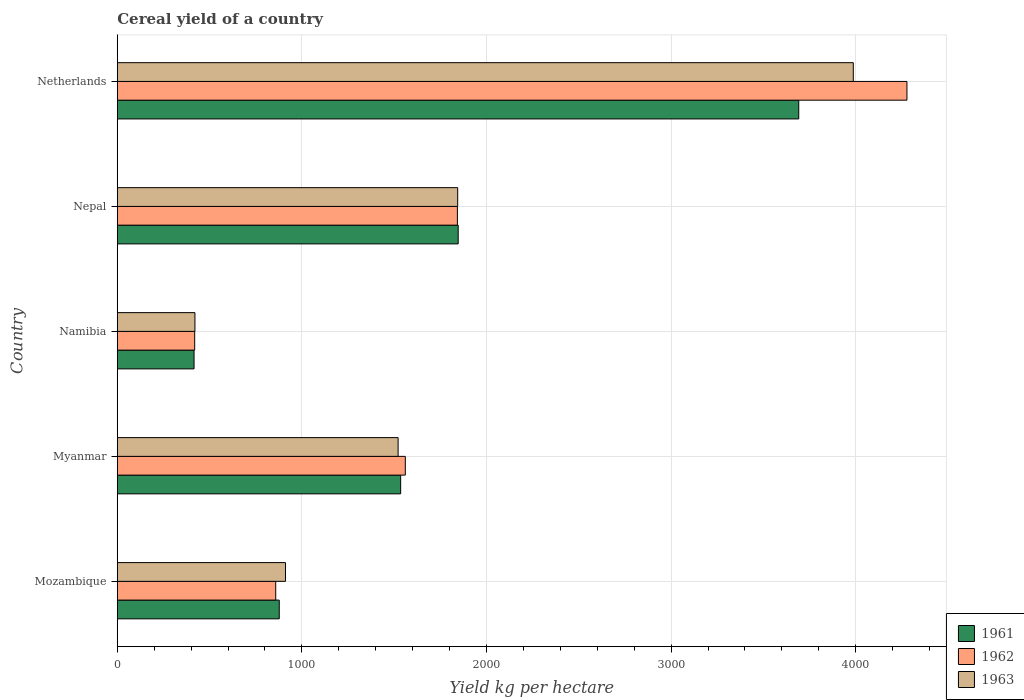How many groups of bars are there?
Provide a short and direct response. 5. Are the number of bars per tick equal to the number of legend labels?
Give a very brief answer. Yes. Are the number of bars on each tick of the Y-axis equal?
Provide a succinct answer. Yes. How many bars are there on the 5th tick from the top?
Provide a succinct answer. 3. How many bars are there on the 2nd tick from the bottom?
Your response must be concise. 3. What is the label of the 2nd group of bars from the top?
Your answer should be compact. Nepal. What is the total cereal yield in 1963 in Namibia?
Your response must be concise. 420.67. Across all countries, what is the maximum total cereal yield in 1961?
Your answer should be compact. 3691.39. Across all countries, what is the minimum total cereal yield in 1963?
Your response must be concise. 420.67. In which country was the total cereal yield in 1961 minimum?
Offer a terse response. Namibia. What is the total total cereal yield in 1961 in the graph?
Keep it short and to the point. 8366.16. What is the difference between the total cereal yield in 1962 in Mozambique and that in Netherlands?
Keep it short and to the point. -3419.19. What is the difference between the total cereal yield in 1963 in Myanmar and the total cereal yield in 1962 in Namibia?
Make the answer very short. 1101.84. What is the average total cereal yield in 1961 per country?
Provide a short and direct response. 1673.23. What is the difference between the total cereal yield in 1961 and total cereal yield in 1962 in Myanmar?
Provide a succinct answer. -25.2. In how many countries, is the total cereal yield in 1962 greater than 600 kg per hectare?
Offer a terse response. 4. What is the ratio of the total cereal yield in 1961 in Mozambique to that in Myanmar?
Your answer should be very brief. 0.57. What is the difference between the highest and the second highest total cereal yield in 1962?
Provide a short and direct response. 2435.14. What is the difference between the highest and the lowest total cereal yield in 1962?
Offer a very short reply. 3858.11. In how many countries, is the total cereal yield in 1961 greater than the average total cereal yield in 1961 taken over all countries?
Ensure brevity in your answer.  2. Is the sum of the total cereal yield in 1961 in Myanmar and Netherlands greater than the maximum total cereal yield in 1962 across all countries?
Make the answer very short. Yes. What does the 2nd bar from the bottom in Netherlands represents?
Offer a terse response. 1962. How many countries are there in the graph?
Provide a short and direct response. 5. Does the graph contain any zero values?
Your answer should be compact. No. How are the legend labels stacked?
Your response must be concise. Vertical. What is the title of the graph?
Your response must be concise. Cereal yield of a country. Does "1967" appear as one of the legend labels in the graph?
Give a very brief answer. No. What is the label or title of the X-axis?
Your response must be concise. Yield kg per hectare. What is the label or title of the Y-axis?
Offer a very short reply. Country. What is the Yield kg per hectare of 1961 in Mozambique?
Keep it short and to the point. 877.38. What is the Yield kg per hectare in 1962 in Mozambique?
Your answer should be very brief. 858.24. What is the Yield kg per hectare of 1963 in Mozambique?
Make the answer very short. 911.12. What is the Yield kg per hectare in 1961 in Myanmar?
Ensure brevity in your answer.  1534.96. What is the Yield kg per hectare in 1962 in Myanmar?
Your answer should be very brief. 1560.16. What is the Yield kg per hectare in 1963 in Myanmar?
Your answer should be very brief. 1521.16. What is the Yield kg per hectare in 1961 in Namibia?
Your response must be concise. 415.79. What is the Yield kg per hectare in 1962 in Namibia?
Your response must be concise. 419.32. What is the Yield kg per hectare of 1963 in Namibia?
Provide a succinct answer. 420.67. What is the Yield kg per hectare of 1961 in Nepal?
Ensure brevity in your answer.  1846.65. What is the Yield kg per hectare of 1962 in Nepal?
Provide a succinct answer. 1842.29. What is the Yield kg per hectare in 1963 in Nepal?
Your answer should be very brief. 1843.86. What is the Yield kg per hectare in 1961 in Netherlands?
Keep it short and to the point. 3691.39. What is the Yield kg per hectare in 1962 in Netherlands?
Provide a succinct answer. 4277.43. What is the Yield kg per hectare of 1963 in Netherlands?
Keep it short and to the point. 3986.86. Across all countries, what is the maximum Yield kg per hectare of 1961?
Offer a very short reply. 3691.39. Across all countries, what is the maximum Yield kg per hectare in 1962?
Your answer should be compact. 4277.43. Across all countries, what is the maximum Yield kg per hectare of 1963?
Your response must be concise. 3986.86. Across all countries, what is the minimum Yield kg per hectare in 1961?
Provide a succinct answer. 415.79. Across all countries, what is the minimum Yield kg per hectare in 1962?
Your answer should be very brief. 419.32. Across all countries, what is the minimum Yield kg per hectare of 1963?
Your response must be concise. 420.67. What is the total Yield kg per hectare of 1961 in the graph?
Offer a terse response. 8366.16. What is the total Yield kg per hectare of 1962 in the graph?
Ensure brevity in your answer.  8957.44. What is the total Yield kg per hectare of 1963 in the graph?
Make the answer very short. 8683.67. What is the difference between the Yield kg per hectare in 1961 in Mozambique and that in Myanmar?
Make the answer very short. -657.59. What is the difference between the Yield kg per hectare in 1962 in Mozambique and that in Myanmar?
Offer a very short reply. -701.92. What is the difference between the Yield kg per hectare in 1963 in Mozambique and that in Myanmar?
Ensure brevity in your answer.  -610.04. What is the difference between the Yield kg per hectare in 1961 in Mozambique and that in Namibia?
Offer a terse response. 461.58. What is the difference between the Yield kg per hectare in 1962 in Mozambique and that in Namibia?
Your answer should be compact. 438.92. What is the difference between the Yield kg per hectare of 1963 in Mozambique and that in Namibia?
Offer a very short reply. 490.45. What is the difference between the Yield kg per hectare in 1961 in Mozambique and that in Nepal?
Offer a terse response. -969.27. What is the difference between the Yield kg per hectare in 1962 in Mozambique and that in Nepal?
Give a very brief answer. -984.05. What is the difference between the Yield kg per hectare of 1963 in Mozambique and that in Nepal?
Ensure brevity in your answer.  -932.74. What is the difference between the Yield kg per hectare in 1961 in Mozambique and that in Netherlands?
Your answer should be very brief. -2814.01. What is the difference between the Yield kg per hectare in 1962 in Mozambique and that in Netherlands?
Ensure brevity in your answer.  -3419.19. What is the difference between the Yield kg per hectare in 1963 in Mozambique and that in Netherlands?
Make the answer very short. -3075.74. What is the difference between the Yield kg per hectare in 1961 in Myanmar and that in Namibia?
Make the answer very short. 1119.17. What is the difference between the Yield kg per hectare in 1962 in Myanmar and that in Namibia?
Ensure brevity in your answer.  1140.84. What is the difference between the Yield kg per hectare in 1963 in Myanmar and that in Namibia?
Give a very brief answer. 1100.5. What is the difference between the Yield kg per hectare in 1961 in Myanmar and that in Nepal?
Your answer should be compact. -311.69. What is the difference between the Yield kg per hectare in 1962 in Myanmar and that in Nepal?
Offer a very short reply. -282.12. What is the difference between the Yield kg per hectare of 1963 in Myanmar and that in Nepal?
Give a very brief answer. -322.69. What is the difference between the Yield kg per hectare of 1961 in Myanmar and that in Netherlands?
Give a very brief answer. -2156.43. What is the difference between the Yield kg per hectare in 1962 in Myanmar and that in Netherlands?
Keep it short and to the point. -2717.27. What is the difference between the Yield kg per hectare of 1963 in Myanmar and that in Netherlands?
Your answer should be compact. -2465.7. What is the difference between the Yield kg per hectare in 1961 in Namibia and that in Nepal?
Offer a very short reply. -1430.85. What is the difference between the Yield kg per hectare of 1962 in Namibia and that in Nepal?
Offer a very short reply. -1422.97. What is the difference between the Yield kg per hectare of 1963 in Namibia and that in Nepal?
Offer a terse response. -1423.19. What is the difference between the Yield kg per hectare in 1961 in Namibia and that in Netherlands?
Provide a short and direct response. -3275.59. What is the difference between the Yield kg per hectare in 1962 in Namibia and that in Netherlands?
Offer a very short reply. -3858.11. What is the difference between the Yield kg per hectare of 1963 in Namibia and that in Netherlands?
Keep it short and to the point. -3566.2. What is the difference between the Yield kg per hectare of 1961 in Nepal and that in Netherlands?
Give a very brief answer. -1844.74. What is the difference between the Yield kg per hectare of 1962 in Nepal and that in Netherlands?
Offer a very short reply. -2435.14. What is the difference between the Yield kg per hectare in 1963 in Nepal and that in Netherlands?
Your answer should be compact. -2143. What is the difference between the Yield kg per hectare in 1961 in Mozambique and the Yield kg per hectare in 1962 in Myanmar?
Provide a succinct answer. -682.79. What is the difference between the Yield kg per hectare of 1961 in Mozambique and the Yield kg per hectare of 1963 in Myanmar?
Give a very brief answer. -643.79. What is the difference between the Yield kg per hectare of 1962 in Mozambique and the Yield kg per hectare of 1963 in Myanmar?
Ensure brevity in your answer.  -662.92. What is the difference between the Yield kg per hectare of 1961 in Mozambique and the Yield kg per hectare of 1962 in Namibia?
Provide a short and direct response. 458.05. What is the difference between the Yield kg per hectare of 1961 in Mozambique and the Yield kg per hectare of 1963 in Namibia?
Make the answer very short. 456.71. What is the difference between the Yield kg per hectare in 1962 in Mozambique and the Yield kg per hectare in 1963 in Namibia?
Make the answer very short. 437.57. What is the difference between the Yield kg per hectare of 1961 in Mozambique and the Yield kg per hectare of 1962 in Nepal?
Provide a short and direct response. -964.91. What is the difference between the Yield kg per hectare of 1961 in Mozambique and the Yield kg per hectare of 1963 in Nepal?
Provide a succinct answer. -966.48. What is the difference between the Yield kg per hectare in 1962 in Mozambique and the Yield kg per hectare in 1963 in Nepal?
Your answer should be very brief. -985.62. What is the difference between the Yield kg per hectare in 1961 in Mozambique and the Yield kg per hectare in 1962 in Netherlands?
Ensure brevity in your answer.  -3400.05. What is the difference between the Yield kg per hectare of 1961 in Mozambique and the Yield kg per hectare of 1963 in Netherlands?
Your answer should be compact. -3109.49. What is the difference between the Yield kg per hectare in 1962 in Mozambique and the Yield kg per hectare in 1963 in Netherlands?
Make the answer very short. -3128.62. What is the difference between the Yield kg per hectare of 1961 in Myanmar and the Yield kg per hectare of 1962 in Namibia?
Provide a short and direct response. 1115.64. What is the difference between the Yield kg per hectare in 1961 in Myanmar and the Yield kg per hectare in 1963 in Namibia?
Give a very brief answer. 1114.29. What is the difference between the Yield kg per hectare in 1962 in Myanmar and the Yield kg per hectare in 1963 in Namibia?
Ensure brevity in your answer.  1139.5. What is the difference between the Yield kg per hectare in 1961 in Myanmar and the Yield kg per hectare in 1962 in Nepal?
Provide a short and direct response. -307.33. What is the difference between the Yield kg per hectare in 1961 in Myanmar and the Yield kg per hectare in 1963 in Nepal?
Your response must be concise. -308.9. What is the difference between the Yield kg per hectare in 1962 in Myanmar and the Yield kg per hectare in 1963 in Nepal?
Provide a short and direct response. -283.7. What is the difference between the Yield kg per hectare in 1961 in Myanmar and the Yield kg per hectare in 1962 in Netherlands?
Give a very brief answer. -2742.47. What is the difference between the Yield kg per hectare of 1961 in Myanmar and the Yield kg per hectare of 1963 in Netherlands?
Your answer should be very brief. -2451.9. What is the difference between the Yield kg per hectare in 1962 in Myanmar and the Yield kg per hectare in 1963 in Netherlands?
Keep it short and to the point. -2426.7. What is the difference between the Yield kg per hectare in 1961 in Namibia and the Yield kg per hectare in 1962 in Nepal?
Your answer should be compact. -1426.49. What is the difference between the Yield kg per hectare of 1961 in Namibia and the Yield kg per hectare of 1963 in Nepal?
Your response must be concise. -1428.07. What is the difference between the Yield kg per hectare of 1962 in Namibia and the Yield kg per hectare of 1963 in Nepal?
Make the answer very short. -1424.54. What is the difference between the Yield kg per hectare in 1961 in Namibia and the Yield kg per hectare in 1962 in Netherlands?
Offer a very short reply. -3861.64. What is the difference between the Yield kg per hectare in 1961 in Namibia and the Yield kg per hectare in 1963 in Netherlands?
Give a very brief answer. -3571.07. What is the difference between the Yield kg per hectare in 1962 in Namibia and the Yield kg per hectare in 1963 in Netherlands?
Offer a terse response. -3567.54. What is the difference between the Yield kg per hectare in 1961 in Nepal and the Yield kg per hectare in 1962 in Netherlands?
Make the answer very short. -2430.78. What is the difference between the Yield kg per hectare of 1961 in Nepal and the Yield kg per hectare of 1963 in Netherlands?
Offer a very short reply. -2140.22. What is the difference between the Yield kg per hectare in 1962 in Nepal and the Yield kg per hectare in 1963 in Netherlands?
Offer a terse response. -2144.57. What is the average Yield kg per hectare in 1961 per country?
Make the answer very short. 1673.23. What is the average Yield kg per hectare in 1962 per country?
Provide a succinct answer. 1791.49. What is the average Yield kg per hectare in 1963 per country?
Your answer should be compact. 1736.73. What is the difference between the Yield kg per hectare of 1961 and Yield kg per hectare of 1962 in Mozambique?
Make the answer very short. 19.13. What is the difference between the Yield kg per hectare of 1961 and Yield kg per hectare of 1963 in Mozambique?
Ensure brevity in your answer.  -33.74. What is the difference between the Yield kg per hectare in 1962 and Yield kg per hectare in 1963 in Mozambique?
Provide a succinct answer. -52.88. What is the difference between the Yield kg per hectare in 1961 and Yield kg per hectare in 1962 in Myanmar?
Your answer should be compact. -25.2. What is the difference between the Yield kg per hectare in 1961 and Yield kg per hectare in 1963 in Myanmar?
Make the answer very short. 13.8. What is the difference between the Yield kg per hectare of 1962 and Yield kg per hectare of 1963 in Myanmar?
Offer a very short reply. 39. What is the difference between the Yield kg per hectare of 1961 and Yield kg per hectare of 1962 in Namibia?
Give a very brief answer. -3.53. What is the difference between the Yield kg per hectare in 1961 and Yield kg per hectare in 1963 in Namibia?
Keep it short and to the point. -4.87. What is the difference between the Yield kg per hectare in 1962 and Yield kg per hectare in 1963 in Namibia?
Offer a terse response. -1.35. What is the difference between the Yield kg per hectare of 1961 and Yield kg per hectare of 1962 in Nepal?
Your answer should be very brief. 4.36. What is the difference between the Yield kg per hectare of 1961 and Yield kg per hectare of 1963 in Nepal?
Your response must be concise. 2.79. What is the difference between the Yield kg per hectare of 1962 and Yield kg per hectare of 1963 in Nepal?
Give a very brief answer. -1.57. What is the difference between the Yield kg per hectare of 1961 and Yield kg per hectare of 1962 in Netherlands?
Offer a very short reply. -586.04. What is the difference between the Yield kg per hectare in 1961 and Yield kg per hectare in 1963 in Netherlands?
Your response must be concise. -295.48. What is the difference between the Yield kg per hectare in 1962 and Yield kg per hectare in 1963 in Netherlands?
Ensure brevity in your answer.  290.57. What is the ratio of the Yield kg per hectare in 1961 in Mozambique to that in Myanmar?
Your response must be concise. 0.57. What is the ratio of the Yield kg per hectare of 1962 in Mozambique to that in Myanmar?
Offer a terse response. 0.55. What is the ratio of the Yield kg per hectare in 1963 in Mozambique to that in Myanmar?
Make the answer very short. 0.6. What is the ratio of the Yield kg per hectare in 1961 in Mozambique to that in Namibia?
Your response must be concise. 2.11. What is the ratio of the Yield kg per hectare in 1962 in Mozambique to that in Namibia?
Ensure brevity in your answer.  2.05. What is the ratio of the Yield kg per hectare of 1963 in Mozambique to that in Namibia?
Give a very brief answer. 2.17. What is the ratio of the Yield kg per hectare of 1961 in Mozambique to that in Nepal?
Offer a very short reply. 0.48. What is the ratio of the Yield kg per hectare in 1962 in Mozambique to that in Nepal?
Keep it short and to the point. 0.47. What is the ratio of the Yield kg per hectare of 1963 in Mozambique to that in Nepal?
Offer a very short reply. 0.49. What is the ratio of the Yield kg per hectare of 1961 in Mozambique to that in Netherlands?
Make the answer very short. 0.24. What is the ratio of the Yield kg per hectare of 1962 in Mozambique to that in Netherlands?
Keep it short and to the point. 0.2. What is the ratio of the Yield kg per hectare in 1963 in Mozambique to that in Netherlands?
Provide a short and direct response. 0.23. What is the ratio of the Yield kg per hectare in 1961 in Myanmar to that in Namibia?
Keep it short and to the point. 3.69. What is the ratio of the Yield kg per hectare of 1962 in Myanmar to that in Namibia?
Ensure brevity in your answer.  3.72. What is the ratio of the Yield kg per hectare of 1963 in Myanmar to that in Namibia?
Your answer should be very brief. 3.62. What is the ratio of the Yield kg per hectare of 1961 in Myanmar to that in Nepal?
Offer a very short reply. 0.83. What is the ratio of the Yield kg per hectare in 1962 in Myanmar to that in Nepal?
Your answer should be very brief. 0.85. What is the ratio of the Yield kg per hectare in 1963 in Myanmar to that in Nepal?
Offer a terse response. 0.82. What is the ratio of the Yield kg per hectare in 1961 in Myanmar to that in Netherlands?
Offer a terse response. 0.42. What is the ratio of the Yield kg per hectare of 1962 in Myanmar to that in Netherlands?
Your answer should be very brief. 0.36. What is the ratio of the Yield kg per hectare of 1963 in Myanmar to that in Netherlands?
Your answer should be very brief. 0.38. What is the ratio of the Yield kg per hectare in 1961 in Namibia to that in Nepal?
Provide a succinct answer. 0.23. What is the ratio of the Yield kg per hectare in 1962 in Namibia to that in Nepal?
Your answer should be compact. 0.23. What is the ratio of the Yield kg per hectare in 1963 in Namibia to that in Nepal?
Offer a very short reply. 0.23. What is the ratio of the Yield kg per hectare in 1961 in Namibia to that in Netherlands?
Offer a very short reply. 0.11. What is the ratio of the Yield kg per hectare in 1962 in Namibia to that in Netherlands?
Ensure brevity in your answer.  0.1. What is the ratio of the Yield kg per hectare of 1963 in Namibia to that in Netherlands?
Provide a succinct answer. 0.11. What is the ratio of the Yield kg per hectare in 1961 in Nepal to that in Netherlands?
Keep it short and to the point. 0.5. What is the ratio of the Yield kg per hectare in 1962 in Nepal to that in Netherlands?
Ensure brevity in your answer.  0.43. What is the ratio of the Yield kg per hectare in 1963 in Nepal to that in Netherlands?
Provide a succinct answer. 0.46. What is the difference between the highest and the second highest Yield kg per hectare in 1961?
Provide a short and direct response. 1844.74. What is the difference between the highest and the second highest Yield kg per hectare in 1962?
Ensure brevity in your answer.  2435.14. What is the difference between the highest and the second highest Yield kg per hectare in 1963?
Your response must be concise. 2143. What is the difference between the highest and the lowest Yield kg per hectare in 1961?
Ensure brevity in your answer.  3275.59. What is the difference between the highest and the lowest Yield kg per hectare in 1962?
Your response must be concise. 3858.11. What is the difference between the highest and the lowest Yield kg per hectare in 1963?
Make the answer very short. 3566.2. 